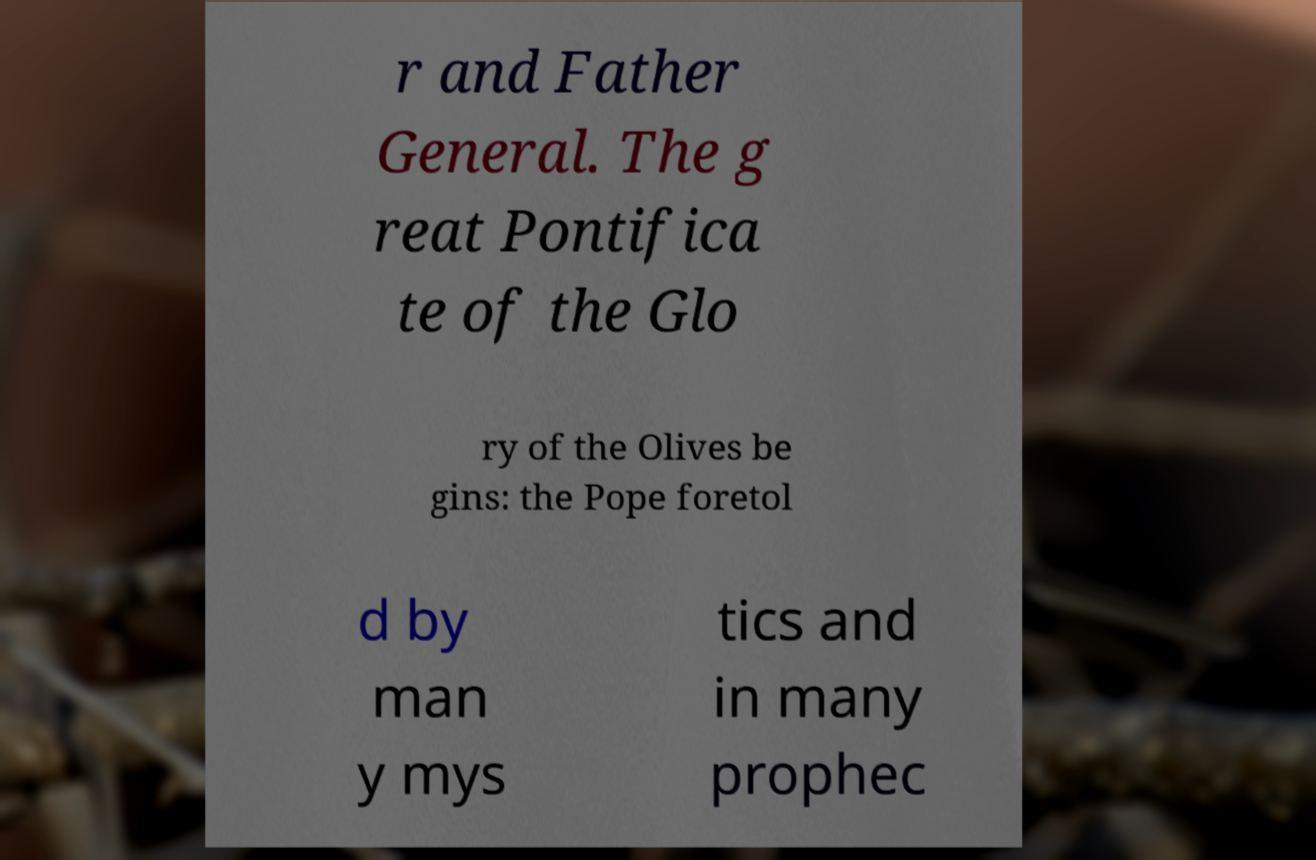Can you accurately transcribe the text from the provided image for me? r and Father General. The g reat Pontifica te of the Glo ry of the Olives be gins: the Pope foretol d by man y mys tics and in many prophec 